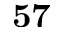<formula> <loc_0><loc_0><loc_500><loc_500>5 7</formula> 